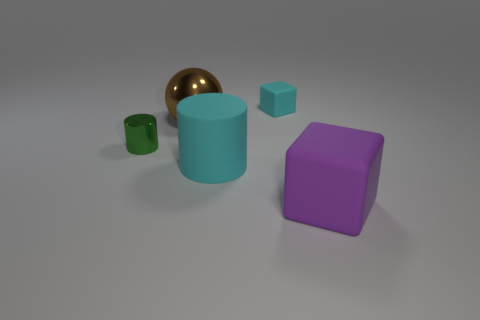There is a small rubber thing that is the same color as the large rubber cylinder; what shape is it?
Make the answer very short. Cube. There is a thing that is both right of the big brown metallic thing and behind the cyan rubber cylinder; what material is it?
Provide a succinct answer. Rubber. How many other objects are the same size as the purple rubber cube?
Your answer should be compact. 2. What color is the small cylinder?
Provide a short and direct response. Green. Is the color of the large matte object on the left side of the small rubber cube the same as the small thing that is behind the shiny ball?
Your answer should be compact. Yes. What size is the metallic cylinder?
Ensure brevity in your answer.  Small. What size is the cyan rubber thing in front of the tiny green shiny cylinder?
Your response must be concise. Large. There is a matte object that is right of the big cyan matte thing and in front of the cyan cube; what is its shape?
Keep it short and to the point. Cube. What number of other objects are the same shape as the brown metallic object?
Provide a succinct answer. 0. The rubber thing that is the same size as the cyan cylinder is what color?
Ensure brevity in your answer.  Purple. 